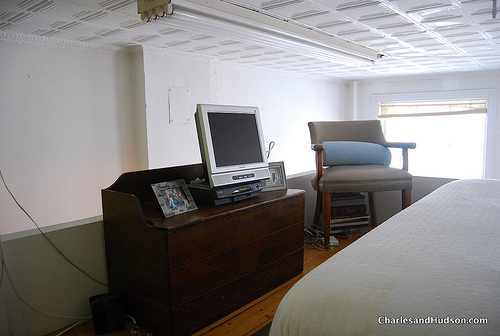What kind of furniture is large? The bed is the large piece of furniture evident in the room. 